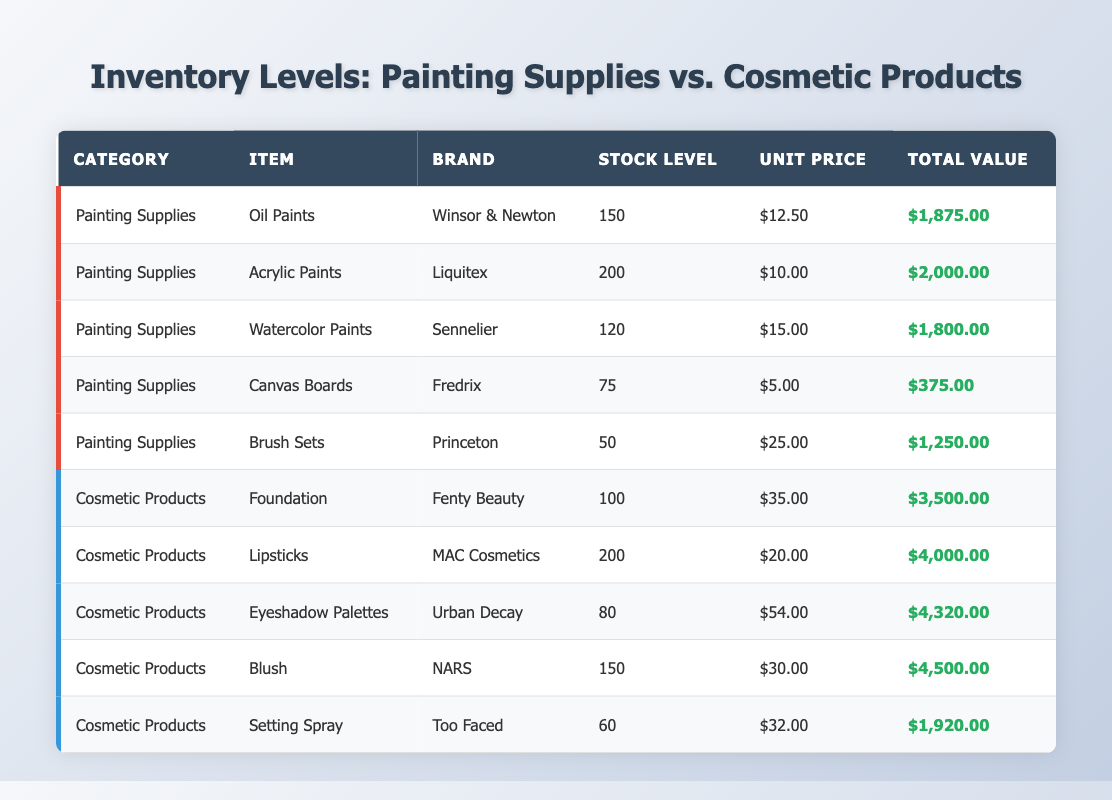What is the stock level of Lipsticks? The table shows that the stock level for Lipsticks under the Cosmetic Products category is 200.
Answer: 200 Which Painting Supply has the highest total value? By looking at the Total Value column in the Painting Supplies section, Oil Paints have a total value of $1,875.00, Acrylic Paints have $2,000.00, Watercolor Paints $1,800.00, Canvas Boards $375.00, and Brush Sets $1,250.00. The highest value is $2,000.00 for Acrylic Paints.
Answer: Acrylic Paints What is the total stock level of all Cosmetic Products? Adding the stock levels: Foundation (100) + Lipsticks (200) + Eyeshadow Palettes (80) + Blush (150) + Setting Spray (60) gives a total of 590.
Answer: 590 What is the average unit price of Painting Supplies? The unit prices are $12.50, $10.00, $15.00, $5.00, and $25.00. Adding these gives $72.50. Dividing by 5 (the number of items) gives an average of $14.50.
Answer: $14.50 Is the total value of Blush greater than that of Setting Spray? The Total Value for Blush is $4,500.00, and for Setting Spray, it is $1,920.00. Since $4,500.00 is greater than $1,920.00, the statement is true.
Answer: Yes What is the total number of items in Painting Supplies? By counting: Oil Paints (1) + Acrylic Paints (1) + Watercolor Paints (1) + Canvas Boards (1) + Brush Sets (1) totals to 5 items.
Answer: 5 Which has a higher average stock level: Painting Supplies or Cosmetic Products? Total stock levels: Painting Supplies (150 + 200 + 120 + 75 + 50 = 595), Cosmetic Products (100 + 200 + 80 + 150 + 60 = 590). Both have 5 items, so averages are 119 for Painting Supplies and 118 for Cosmetic Products. Thus, Painting Supplies have a higher average.
Answer: Painting Supplies What is the total value difference between the highest and lowest Cosmetic Product? The highest total value is $4,500.00 for Blush, and the lowest is $1,920.00 for Setting Spray. The difference is $4,500.00 - $1,920.00 = $2,580.00.
Answer: $2,580.00 Are there more sets of Brushes than Canvas Boards? The stock level for Brush Sets is 50, and for Canvas Boards, it is 75. Since 50 is less than 75, the statement is false.
Answer: No What is the total value of all Painting Supplies combined? The total values are $1,875.00 (Oil Paints) + $2,000.00 (Acrylic Paints) + $1,800.00 (Watercolor Paints) + $375.00 (Canvas Boards) + $1,250.00 (Brush Sets), which sums to $7,300.00.
Answer: $7,300.00 